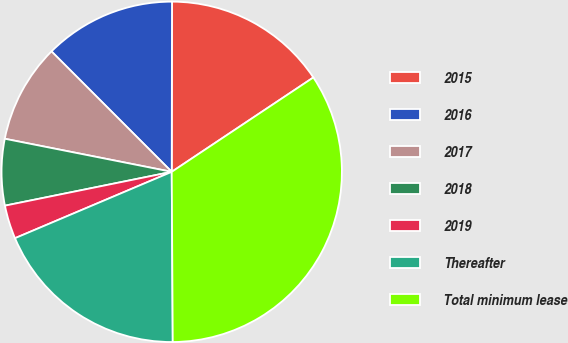Convert chart. <chart><loc_0><loc_0><loc_500><loc_500><pie_chart><fcel>2015<fcel>2016<fcel>2017<fcel>2018<fcel>2019<fcel>Thereafter<fcel>Total minimum lease<nl><fcel>15.62%<fcel>12.51%<fcel>9.4%<fcel>6.3%<fcel>3.19%<fcel>18.72%<fcel>34.26%<nl></chart> 